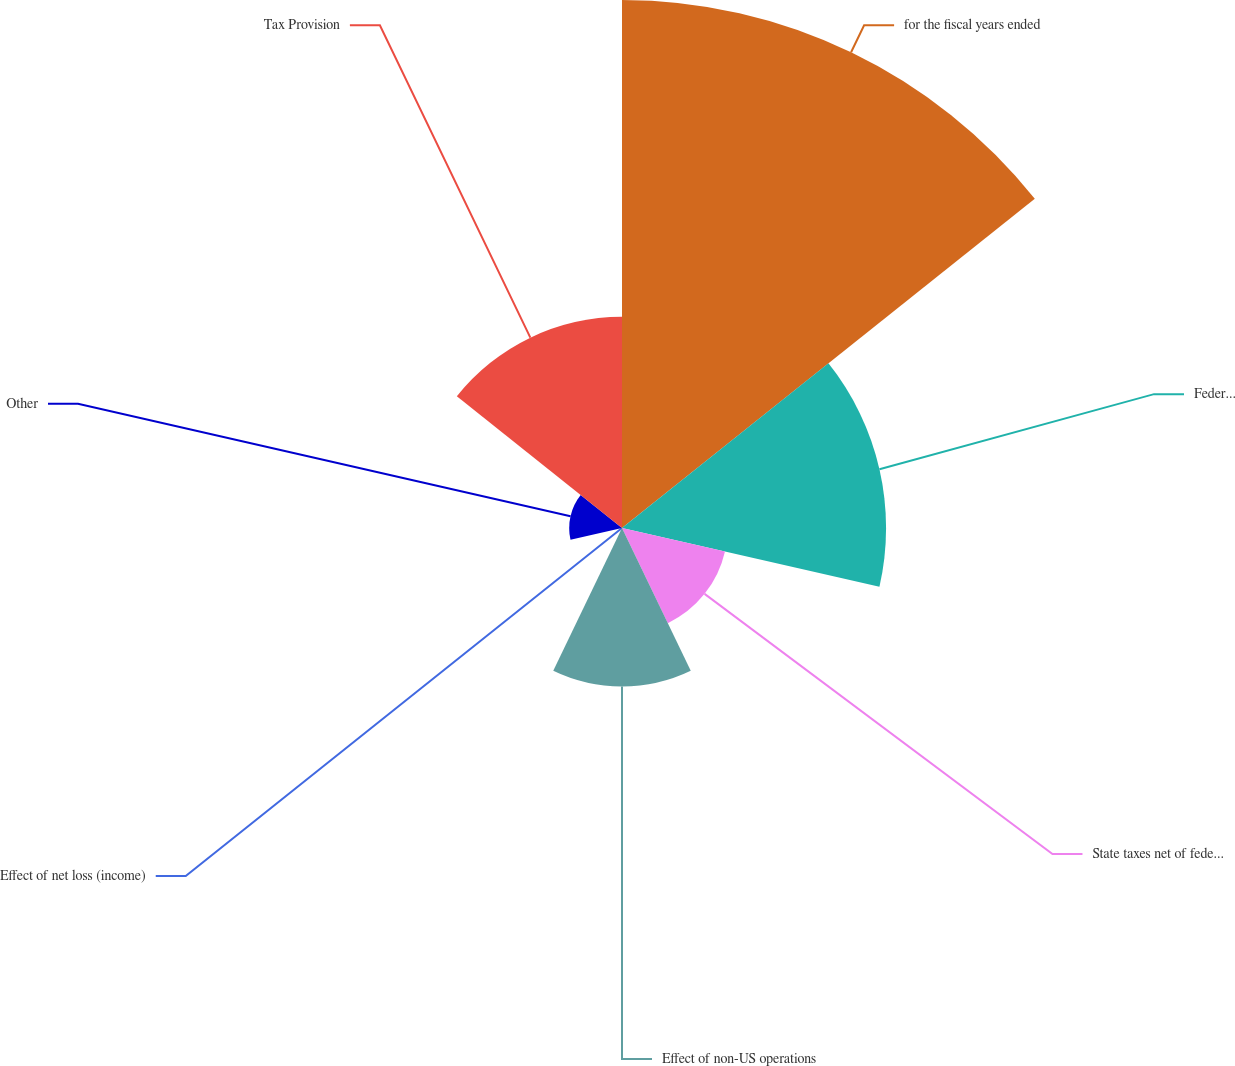<chart> <loc_0><loc_0><loc_500><loc_500><pie_chart><fcel>for the fiscal years ended<fcel>Federal taxes at statutory<fcel>State taxes net of federal tax<fcel>Effect of non-US operations<fcel>Effect of net loss (income)<fcel>Other<fcel>Tax Provision<nl><fcel>39.99%<fcel>20.0%<fcel>8.0%<fcel>12.0%<fcel>0.0%<fcel>4.0%<fcel>16.0%<nl></chart> 